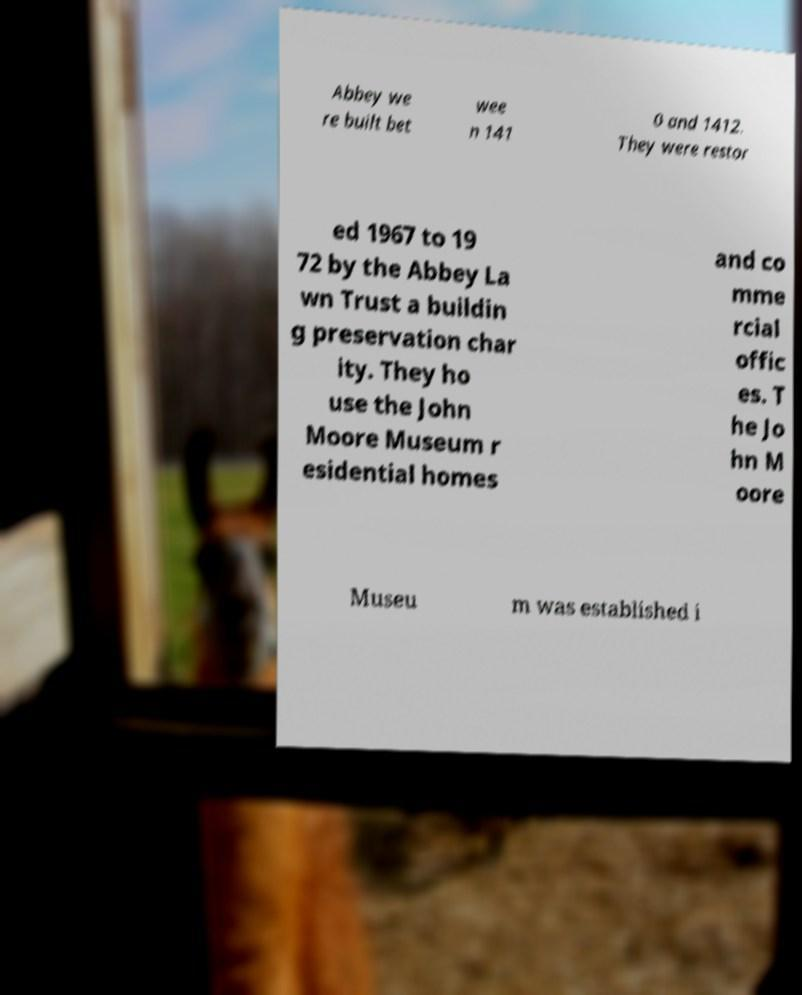I need the written content from this picture converted into text. Can you do that? Abbey we re built bet wee n 141 0 and 1412. They were restor ed 1967 to 19 72 by the Abbey La wn Trust a buildin g preservation char ity. They ho use the John Moore Museum r esidential homes and co mme rcial offic es. T he Jo hn M oore Museu m was established i 